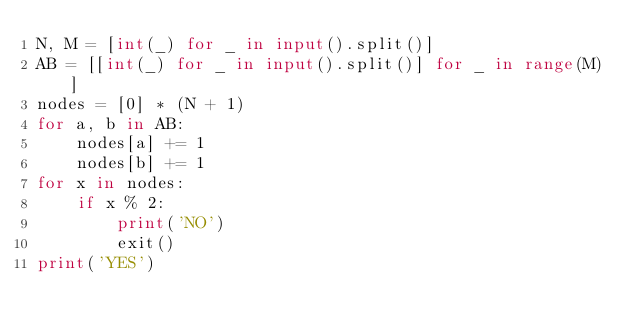Convert code to text. <code><loc_0><loc_0><loc_500><loc_500><_Python_>N, M = [int(_) for _ in input().split()]
AB = [[int(_) for _ in input().split()] for _ in range(M)]
nodes = [0] * (N + 1)
for a, b in AB:
    nodes[a] += 1
    nodes[b] += 1
for x in nodes:
    if x % 2:
        print('NO')
        exit()
print('YES')
</code> 